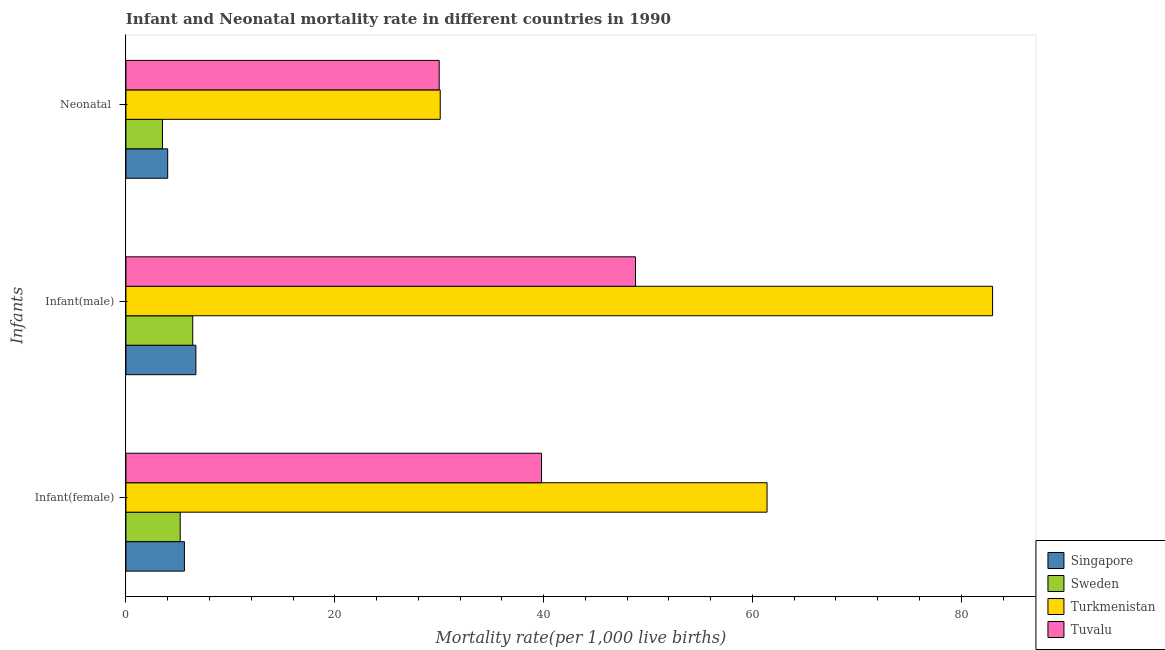How many different coloured bars are there?
Provide a short and direct response. 4. Are the number of bars per tick equal to the number of legend labels?
Offer a very short reply. Yes. Are the number of bars on each tick of the Y-axis equal?
Provide a succinct answer. Yes. How many bars are there on the 3rd tick from the top?
Keep it short and to the point. 4. How many bars are there on the 2nd tick from the bottom?
Ensure brevity in your answer.  4. What is the label of the 2nd group of bars from the top?
Make the answer very short. Infant(male). What is the infant mortality rate(female) in Turkmenistan?
Your answer should be very brief. 61.4. Across all countries, what is the maximum infant mortality rate(male)?
Give a very brief answer. 83. Across all countries, what is the minimum infant mortality rate(male)?
Ensure brevity in your answer.  6.4. In which country was the infant mortality rate(male) maximum?
Make the answer very short. Turkmenistan. What is the total infant mortality rate(female) in the graph?
Give a very brief answer. 112. What is the difference between the infant mortality rate(male) in Singapore and that in Turkmenistan?
Offer a very short reply. -76.3. What is the difference between the neonatal mortality rate in Turkmenistan and the infant mortality rate(male) in Tuvalu?
Your answer should be very brief. -18.7. What is the average infant mortality rate(female) per country?
Provide a short and direct response. 28. What is the difference between the neonatal mortality rate and infant mortality rate(female) in Singapore?
Offer a terse response. -1.6. In how many countries, is the neonatal mortality rate greater than 76 ?
Your answer should be very brief. 0. What is the ratio of the infant mortality rate(female) in Tuvalu to that in Sweden?
Provide a short and direct response. 7.65. Is the infant mortality rate(female) in Turkmenistan less than that in Sweden?
Your answer should be very brief. No. What is the difference between the highest and the second highest infant mortality rate(female)?
Offer a terse response. 21.6. What is the difference between the highest and the lowest infant mortality rate(male)?
Offer a very short reply. 76.6. In how many countries, is the infant mortality rate(male) greater than the average infant mortality rate(male) taken over all countries?
Give a very brief answer. 2. Is the sum of the neonatal mortality rate in Turkmenistan and Tuvalu greater than the maximum infant mortality rate(male) across all countries?
Keep it short and to the point. No. What does the 3rd bar from the top in Infant(male) represents?
Provide a succinct answer. Sweden. How many countries are there in the graph?
Your response must be concise. 4. What is the difference between two consecutive major ticks on the X-axis?
Provide a succinct answer. 20. Are the values on the major ticks of X-axis written in scientific E-notation?
Offer a very short reply. No. Where does the legend appear in the graph?
Make the answer very short. Bottom right. How many legend labels are there?
Provide a short and direct response. 4. How are the legend labels stacked?
Provide a short and direct response. Vertical. What is the title of the graph?
Provide a short and direct response. Infant and Neonatal mortality rate in different countries in 1990. What is the label or title of the X-axis?
Offer a terse response. Mortality rate(per 1,0 live births). What is the label or title of the Y-axis?
Your answer should be compact. Infants. What is the Mortality rate(per 1,000 live births) of Turkmenistan in Infant(female)?
Make the answer very short. 61.4. What is the Mortality rate(per 1,000 live births) in Tuvalu in Infant(female)?
Make the answer very short. 39.8. What is the Mortality rate(per 1,000 live births) in Sweden in Infant(male)?
Give a very brief answer. 6.4. What is the Mortality rate(per 1,000 live births) in Turkmenistan in Infant(male)?
Keep it short and to the point. 83. What is the Mortality rate(per 1,000 live births) of Tuvalu in Infant(male)?
Offer a terse response. 48.8. What is the Mortality rate(per 1,000 live births) in Singapore in Neonatal ?
Ensure brevity in your answer.  4. What is the Mortality rate(per 1,000 live births) of Sweden in Neonatal ?
Your answer should be compact. 3.5. What is the Mortality rate(per 1,000 live births) in Turkmenistan in Neonatal ?
Make the answer very short. 30.1. Across all Infants, what is the maximum Mortality rate(per 1,000 live births) in Singapore?
Provide a succinct answer. 6.7. Across all Infants, what is the maximum Mortality rate(per 1,000 live births) of Sweden?
Ensure brevity in your answer.  6.4. Across all Infants, what is the maximum Mortality rate(per 1,000 live births) in Tuvalu?
Make the answer very short. 48.8. Across all Infants, what is the minimum Mortality rate(per 1,000 live births) in Singapore?
Keep it short and to the point. 4. Across all Infants, what is the minimum Mortality rate(per 1,000 live births) in Sweden?
Give a very brief answer. 3.5. Across all Infants, what is the minimum Mortality rate(per 1,000 live births) in Turkmenistan?
Keep it short and to the point. 30.1. Across all Infants, what is the minimum Mortality rate(per 1,000 live births) of Tuvalu?
Your answer should be compact. 30. What is the total Mortality rate(per 1,000 live births) in Singapore in the graph?
Keep it short and to the point. 16.3. What is the total Mortality rate(per 1,000 live births) of Sweden in the graph?
Your answer should be compact. 15.1. What is the total Mortality rate(per 1,000 live births) of Turkmenistan in the graph?
Offer a very short reply. 174.5. What is the total Mortality rate(per 1,000 live births) of Tuvalu in the graph?
Provide a short and direct response. 118.6. What is the difference between the Mortality rate(per 1,000 live births) in Turkmenistan in Infant(female) and that in Infant(male)?
Your answer should be very brief. -21.6. What is the difference between the Mortality rate(per 1,000 live births) in Singapore in Infant(female) and that in Neonatal ?
Ensure brevity in your answer.  1.6. What is the difference between the Mortality rate(per 1,000 live births) in Sweden in Infant(female) and that in Neonatal ?
Offer a very short reply. 1.7. What is the difference between the Mortality rate(per 1,000 live births) of Turkmenistan in Infant(female) and that in Neonatal ?
Give a very brief answer. 31.3. What is the difference between the Mortality rate(per 1,000 live births) in Sweden in Infant(male) and that in Neonatal ?
Provide a short and direct response. 2.9. What is the difference between the Mortality rate(per 1,000 live births) of Turkmenistan in Infant(male) and that in Neonatal ?
Ensure brevity in your answer.  52.9. What is the difference between the Mortality rate(per 1,000 live births) of Singapore in Infant(female) and the Mortality rate(per 1,000 live births) of Turkmenistan in Infant(male)?
Offer a very short reply. -77.4. What is the difference between the Mortality rate(per 1,000 live births) of Singapore in Infant(female) and the Mortality rate(per 1,000 live births) of Tuvalu in Infant(male)?
Offer a terse response. -43.2. What is the difference between the Mortality rate(per 1,000 live births) in Sweden in Infant(female) and the Mortality rate(per 1,000 live births) in Turkmenistan in Infant(male)?
Your answer should be compact. -77.8. What is the difference between the Mortality rate(per 1,000 live births) of Sweden in Infant(female) and the Mortality rate(per 1,000 live births) of Tuvalu in Infant(male)?
Make the answer very short. -43.6. What is the difference between the Mortality rate(per 1,000 live births) of Turkmenistan in Infant(female) and the Mortality rate(per 1,000 live births) of Tuvalu in Infant(male)?
Give a very brief answer. 12.6. What is the difference between the Mortality rate(per 1,000 live births) in Singapore in Infant(female) and the Mortality rate(per 1,000 live births) in Sweden in Neonatal ?
Keep it short and to the point. 2.1. What is the difference between the Mortality rate(per 1,000 live births) in Singapore in Infant(female) and the Mortality rate(per 1,000 live births) in Turkmenistan in Neonatal ?
Give a very brief answer. -24.5. What is the difference between the Mortality rate(per 1,000 live births) of Singapore in Infant(female) and the Mortality rate(per 1,000 live births) of Tuvalu in Neonatal ?
Make the answer very short. -24.4. What is the difference between the Mortality rate(per 1,000 live births) in Sweden in Infant(female) and the Mortality rate(per 1,000 live births) in Turkmenistan in Neonatal ?
Ensure brevity in your answer.  -24.9. What is the difference between the Mortality rate(per 1,000 live births) of Sweden in Infant(female) and the Mortality rate(per 1,000 live births) of Tuvalu in Neonatal ?
Offer a terse response. -24.8. What is the difference between the Mortality rate(per 1,000 live births) of Turkmenistan in Infant(female) and the Mortality rate(per 1,000 live births) of Tuvalu in Neonatal ?
Your response must be concise. 31.4. What is the difference between the Mortality rate(per 1,000 live births) in Singapore in Infant(male) and the Mortality rate(per 1,000 live births) in Sweden in Neonatal ?
Provide a short and direct response. 3.2. What is the difference between the Mortality rate(per 1,000 live births) in Singapore in Infant(male) and the Mortality rate(per 1,000 live births) in Turkmenistan in Neonatal ?
Provide a short and direct response. -23.4. What is the difference between the Mortality rate(per 1,000 live births) in Singapore in Infant(male) and the Mortality rate(per 1,000 live births) in Tuvalu in Neonatal ?
Offer a terse response. -23.3. What is the difference between the Mortality rate(per 1,000 live births) of Sweden in Infant(male) and the Mortality rate(per 1,000 live births) of Turkmenistan in Neonatal ?
Ensure brevity in your answer.  -23.7. What is the difference between the Mortality rate(per 1,000 live births) of Sweden in Infant(male) and the Mortality rate(per 1,000 live births) of Tuvalu in Neonatal ?
Offer a very short reply. -23.6. What is the difference between the Mortality rate(per 1,000 live births) in Turkmenistan in Infant(male) and the Mortality rate(per 1,000 live births) in Tuvalu in Neonatal ?
Ensure brevity in your answer.  53. What is the average Mortality rate(per 1,000 live births) in Singapore per Infants?
Offer a very short reply. 5.43. What is the average Mortality rate(per 1,000 live births) in Sweden per Infants?
Your response must be concise. 5.03. What is the average Mortality rate(per 1,000 live births) in Turkmenistan per Infants?
Offer a very short reply. 58.17. What is the average Mortality rate(per 1,000 live births) in Tuvalu per Infants?
Offer a very short reply. 39.53. What is the difference between the Mortality rate(per 1,000 live births) of Singapore and Mortality rate(per 1,000 live births) of Sweden in Infant(female)?
Your response must be concise. 0.4. What is the difference between the Mortality rate(per 1,000 live births) of Singapore and Mortality rate(per 1,000 live births) of Turkmenistan in Infant(female)?
Keep it short and to the point. -55.8. What is the difference between the Mortality rate(per 1,000 live births) in Singapore and Mortality rate(per 1,000 live births) in Tuvalu in Infant(female)?
Ensure brevity in your answer.  -34.2. What is the difference between the Mortality rate(per 1,000 live births) of Sweden and Mortality rate(per 1,000 live births) of Turkmenistan in Infant(female)?
Offer a very short reply. -56.2. What is the difference between the Mortality rate(per 1,000 live births) in Sweden and Mortality rate(per 1,000 live births) in Tuvalu in Infant(female)?
Give a very brief answer. -34.6. What is the difference between the Mortality rate(per 1,000 live births) of Turkmenistan and Mortality rate(per 1,000 live births) of Tuvalu in Infant(female)?
Your answer should be compact. 21.6. What is the difference between the Mortality rate(per 1,000 live births) in Singapore and Mortality rate(per 1,000 live births) in Turkmenistan in Infant(male)?
Make the answer very short. -76.3. What is the difference between the Mortality rate(per 1,000 live births) of Singapore and Mortality rate(per 1,000 live births) of Tuvalu in Infant(male)?
Keep it short and to the point. -42.1. What is the difference between the Mortality rate(per 1,000 live births) in Sweden and Mortality rate(per 1,000 live births) in Turkmenistan in Infant(male)?
Keep it short and to the point. -76.6. What is the difference between the Mortality rate(per 1,000 live births) of Sweden and Mortality rate(per 1,000 live births) of Tuvalu in Infant(male)?
Ensure brevity in your answer.  -42.4. What is the difference between the Mortality rate(per 1,000 live births) in Turkmenistan and Mortality rate(per 1,000 live births) in Tuvalu in Infant(male)?
Your answer should be very brief. 34.2. What is the difference between the Mortality rate(per 1,000 live births) of Singapore and Mortality rate(per 1,000 live births) of Sweden in Neonatal ?
Provide a succinct answer. 0.5. What is the difference between the Mortality rate(per 1,000 live births) in Singapore and Mortality rate(per 1,000 live births) in Turkmenistan in Neonatal ?
Give a very brief answer. -26.1. What is the difference between the Mortality rate(per 1,000 live births) of Sweden and Mortality rate(per 1,000 live births) of Turkmenistan in Neonatal ?
Your answer should be very brief. -26.6. What is the difference between the Mortality rate(per 1,000 live births) in Sweden and Mortality rate(per 1,000 live births) in Tuvalu in Neonatal ?
Provide a short and direct response. -26.5. What is the ratio of the Mortality rate(per 1,000 live births) of Singapore in Infant(female) to that in Infant(male)?
Your answer should be compact. 0.84. What is the ratio of the Mortality rate(per 1,000 live births) in Sweden in Infant(female) to that in Infant(male)?
Offer a very short reply. 0.81. What is the ratio of the Mortality rate(per 1,000 live births) in Turkmenistan in Infant(female) to that in Infant(male)?
Provide a succinct answer. 0.74. What is the ratio of the Mortality rate(per 1,000 live births) in Tuvalu in Infant(female) to that in Infant(male)?
Your answer should be very brief. 0.82. What is the ratio of the Mortality rate(per 1,000 live births) of Singapore in Infant(female) to that in Neonatal ?
Your answer should be compact. 1.4. What is the ratio of the Mortality rate(per 1,000 live births) in Sweden in Infant(female) to that in Neonatal ?
Your answer should be compact. 1.49. What is the ratio of the Mortality rate(per 1,000 live births) in Turkmenistan in Infant(female) to that in Neonatal ?
Provide a short and direct response. 2.04. What is the ratio of the Mortality rate(per 1,000 live births) of Tuvalu in Infant(female) to that in Neonatal ?
Provide a short and direct response. 1.33. What is the ratio of the Mortality rate(per 1,000 live births) in Singapore in Infant(male) to that in Neonatal ?
Your answer should be compact. 1.68. What is the ratio of the Mortality rate(per 1,000 live births) of Sweden in Infant(male) to that in Neonatal ?
Give a very brief answer. 1.83. What is the ratio of the Mortality rate(per 1,000 live births) of Turkmenistan in Infant(male) to that in Neonatal ?
Offer a very short reply. 2.76. What is the ratio of the Mortality rate(per 1,000 live births) in Tuvalu in Infant(male) to that in Neonatal ?
Offer a very short reply. 1.63. What is the difference between the highest and the second highest Mortality rate(per 1,000 live births) of Singapore?
Your answer should be very brief. 1.1. What is the difference between the highest and the second highest Mortality rate(per 1,000 live births) of Turkmenistan?
Offer a terse response. 21.6. What is the difference between the highest and the second highest Mortality rate(per 1,000 live births) in Tuvalu?
Provide a short and direct response. 9. What is the difference between the highest and the lowest Mortality rate(per 1,000 live births) in Singapore?
Make the answer very short. 2.7. What is the difference between the highest and the lowest Mortality rate(per 1,000 live births) in Sweden?
Your answer should be very brief. 2.9. What is the difference between the highest and the lowest Mortality rate(per 1,000 live births) in Turkmenistan?
Your response must be concise. 52.9. 